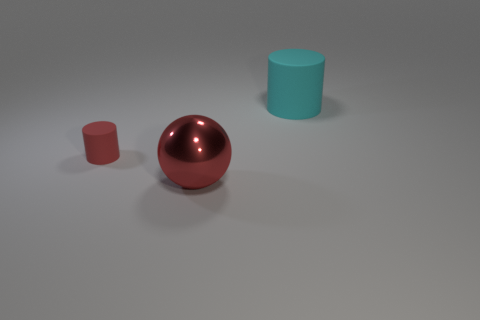Is there any other thing that has the same size as the red matte cylinder?
Make the answer very short. No. There is a tiny thing; what shape is it?
Give a very brief answer. Cylinder. What is the large thing to the right of the big ball made of?
Provide a short and direct response. Rubber. How big is the thing that is in front of the cylinder that is on the left side of the cylinder on the right side of the tiny red object?
Your answer should be compact. Large. Do the thing to the left of the shiny sphere and the big object that is in front of the large cyan cylinder have the same material?
Provide a short and direct response. No. What number of other objects are the same color as the small cylinder?
Your answer should be very brief. 1. What number of things are objects behind the red shiny object or objects to the right of the tiny red matte cylinder?
Provide a succinct answer. 3. There is a rubber cylinder to the right of the thing that is in front of the red rubber thing; what is its size?
Your response must be concise. Large. What size is the metal object?
Provide a short and direct response. Large. There is a cylinder behind the red rubber cylinder; is its color the same as the thing left of the red ball?
Your answer should be compact. No. 